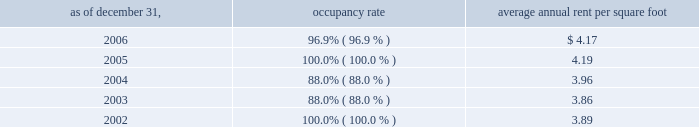Properties 51vornado realty trust industrial properties our dry warehouse/industrial properties consist of seven buildings in new jersey containing approximately 1.5 million square feet .
The properties are encumbered by two cross-collateralized mortgage loans aggregating $ 47179000 as of december 31 , 2006 .
Average lease terms range from three to five years .
The table sets forth the occupancy rate and average annual rent per square foot at the end of each of the past five years .
Average annual occupancy rent per as of december 31 , rate square foot .
220 central park south , new york city we own a 90% ( 90 % ) interest in 220 central park south .
The property contains 122 rental apartments with an aggregate of 133000 square feet and 5700 square feet of commercial space .
On november 7 , 2006 , we completed a $ 130000000 refinancing of the property .
The loan has two tranches : the first tranche of $ 95000000 bears interest at libor ( capped at 5.50% ( 5.50 % ) ) plus 2.35% ( 2.35 % ) ( 7.70% ( 7.70 % ) as of december 31 , 2006 ) and the second tranche can be drawn up to $ 35000000 and bears interest at libor ( capped at 5.50% ( 5.50 % ) ) plus 2.45% ( 2.45 % ) ( 7.80% ( 7.80 % ) as of december 31 , 2006 ) .
As of december 31 , 2006 , approximately $ 27990000 has been drawn on the second tranche .
40 east 66th street , new york city 40 east 66th street , located at madison avenue and east 66th street , contains 37 rental apartments with an aggregate of 85000 square feet , and 10000 square feet of retail space .
The rental apartment operations are included in our other segment and the retail operations are included in the retail segment. .
Average annual rent per square foot changed in 2005 from 2004 by what amount? 
Computations: (4.19 * 3.96)
Answer: 16.5924. 